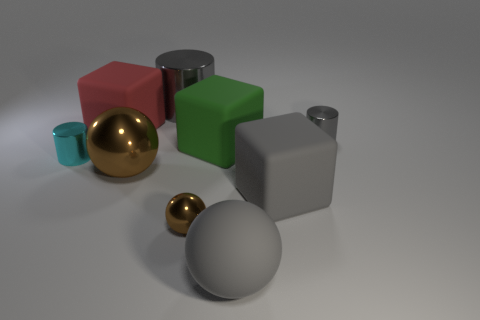Subtract 1 cylinders. How many cylinders are left? 2 Add 1 large purple rubber blocks. How many objects exist? 10 Subtract all cubes. How many objects are left? 6 Subtract all tiny blue matte objects. Subtract all big shiny balls. How many objects are left? 8 Add 6 cubes. How many cubes are left? 9 Add 4 big red matte things. How many big red matte things exist? 5 Subtract 0 purple blocks. How many objects are left? 9 